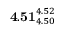<formula> <loc_0><loc_0><loc_500><loc_500>4 . 5 1 _ { 4 . 5 0 } ^ { 4 . 5 2 }</formula> 